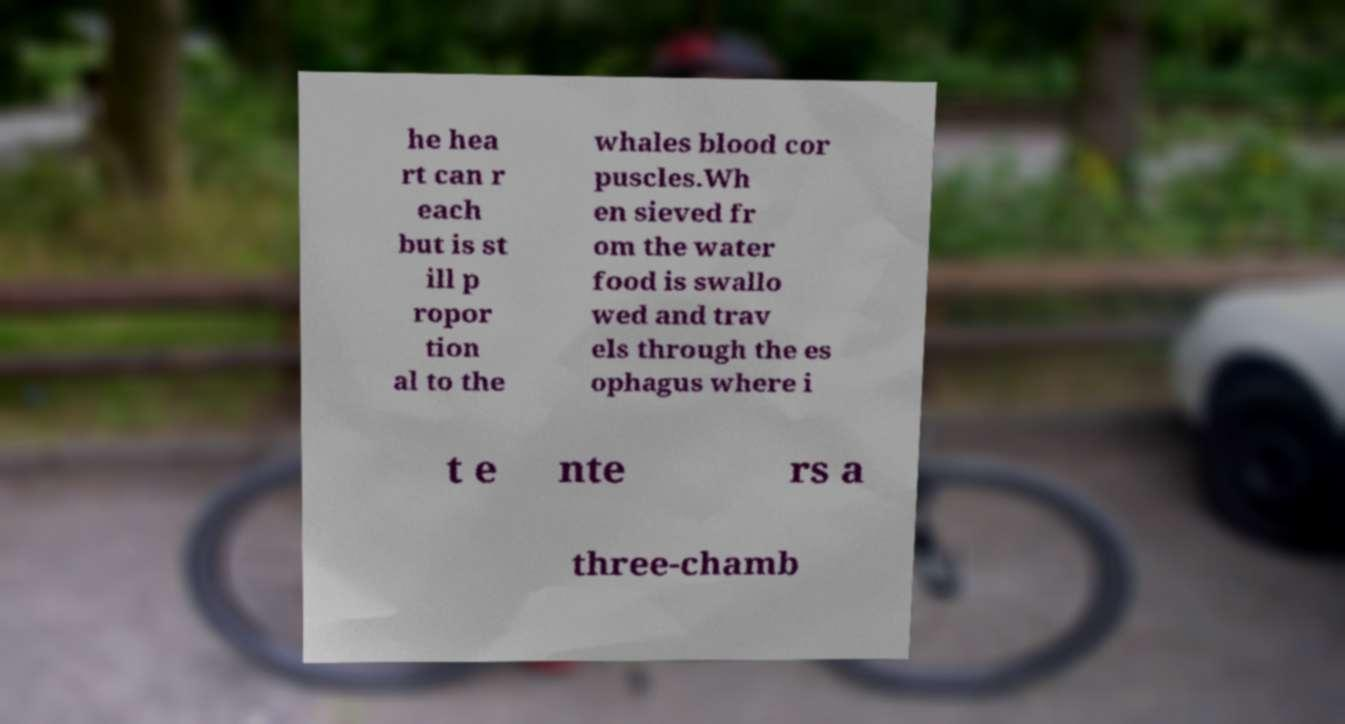Can you read and provide the text displayed in the image?This photo seems to have some interesting text. Can you extract and type it out for me? he hea rt can r each but is st ill p ropor tion al to the whales blood cor puscles.Wh en sieved fr om the water food is swallo wed and trav els through the es ophagus where i t e nte rs a three-chamb 